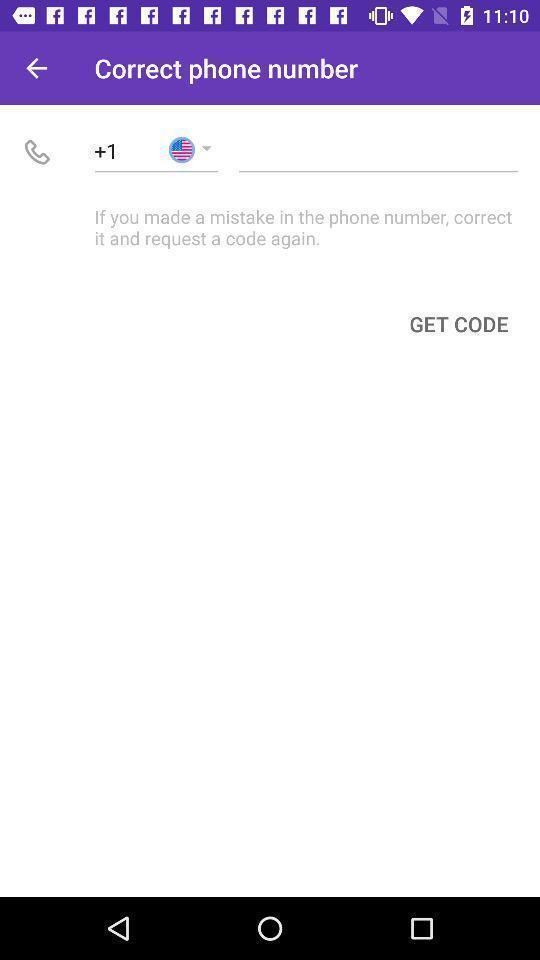What details can you identify in this image? Screen page. 